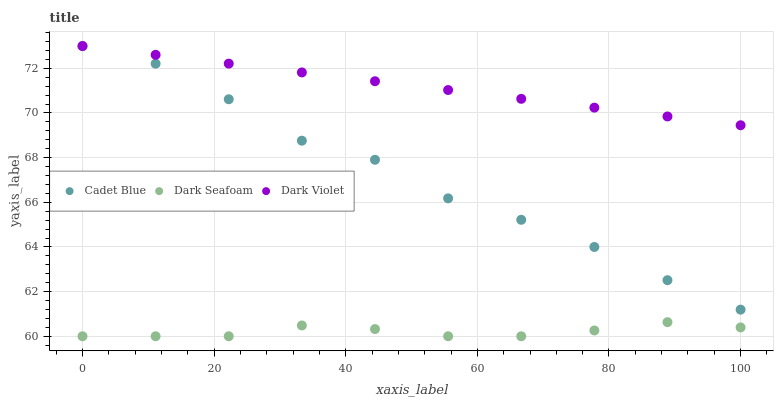Does Dark Seafoam have the minimum area under the curve?
Answer yes or no. Yes. Does Dark Violet have the maximum area under the curve?
Answer yes or no. Yes. Does Cadet Blue have the minimum area under the curve?
Answer yes or no. No. Does Cadet Blue have the maximum area under the curve?
Answer yes or no. No. Is Dark Violet the smoothest?
Answer yes or no. Yes. Is Cadet Blue the roughest?
Answer yes or no. Yes. Is Cadet Blue the smoothest?
Answer yes or no. No. Is Dark Violet the roughest?
Answer yes or no. No. Does Dark Seafoam have the lowest value?
Answer yes or no. Yes. Does Cadet Blue have the lowest value?
Answer yes or no. No. Does Dark Violet have the highest value?
Answer yes or no. Yes. Does Cadet Blue have the highest value?
Answer yes or no. No. Is Dark Seafoam less than Dark Violet?
Answer yes or no. Yes. Is Dark Violet greater than Cadet Blue?
Answer yes or no. Yes. Does Dark Seafoam intersect Dark Violet?
Answer yes or no. No. 